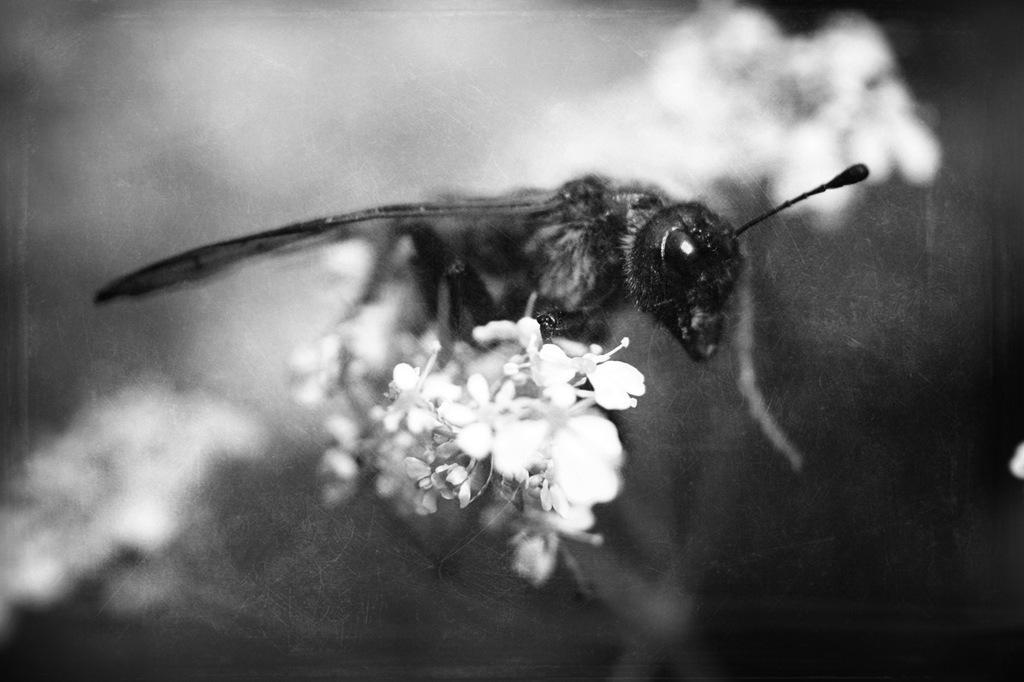In one or two sentences, can you explain what this image depicts? In this picture we can observe an insect on the white color flowers. The background is completely blurred. This is a black and white image. 